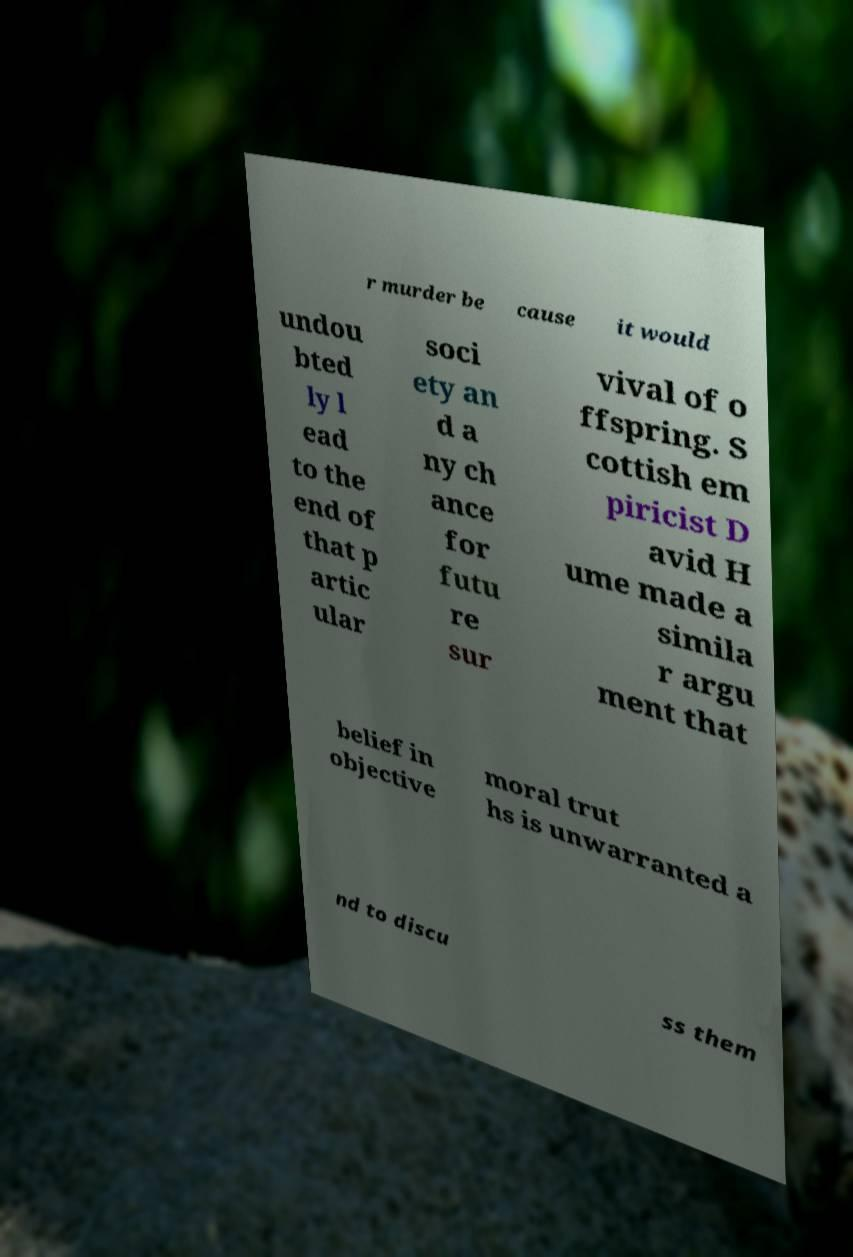What messages or text are displayed in this image? I need them in a readable, typed format. r murder be cause it would undou bted ly l ead to the end of that p artic ular soci ety an d a ny ch ance for futu re sur vival of o ffspring. S cottish em piricist D avid H ume made a simila r argu ment that belief in objective moral trut hs is unwarranted a nd to discu ss them 